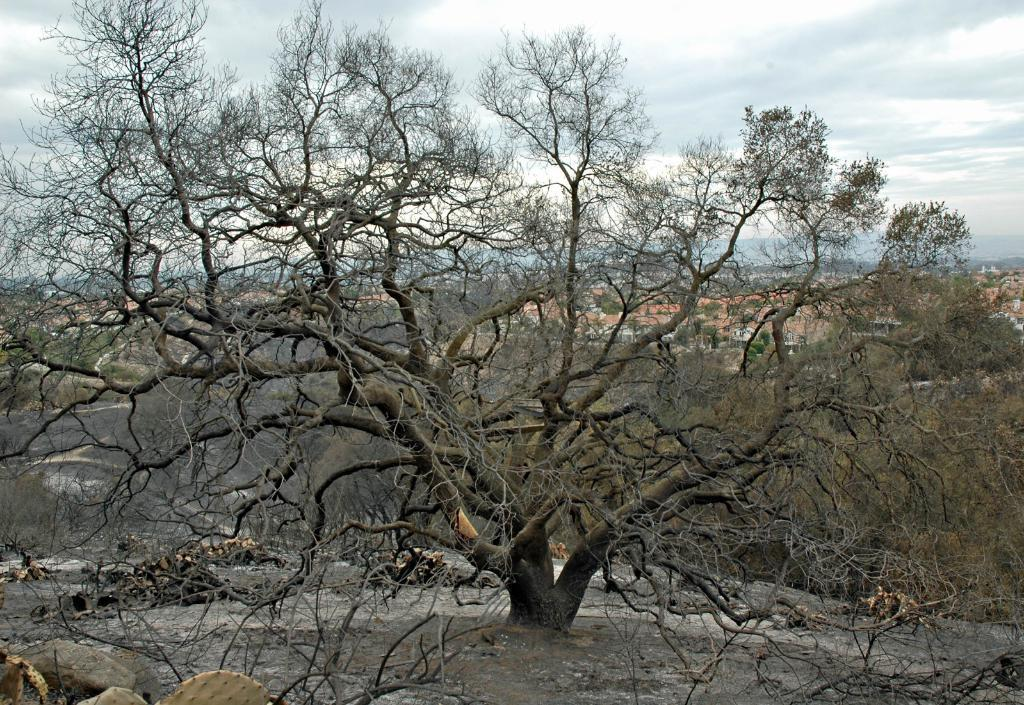What is the main subject in the center of the image? There is a tree in the center of the image. What can be seen at the bottom side of the image? There is water at the bottom side of the image. What is visible in the background of the image? There are trees and buildings in the background of the image. Where is the baby sitting in the image? There is no baby present in the image. What type of cannon is located near the tree in the image? There is no cannon present in the image. 